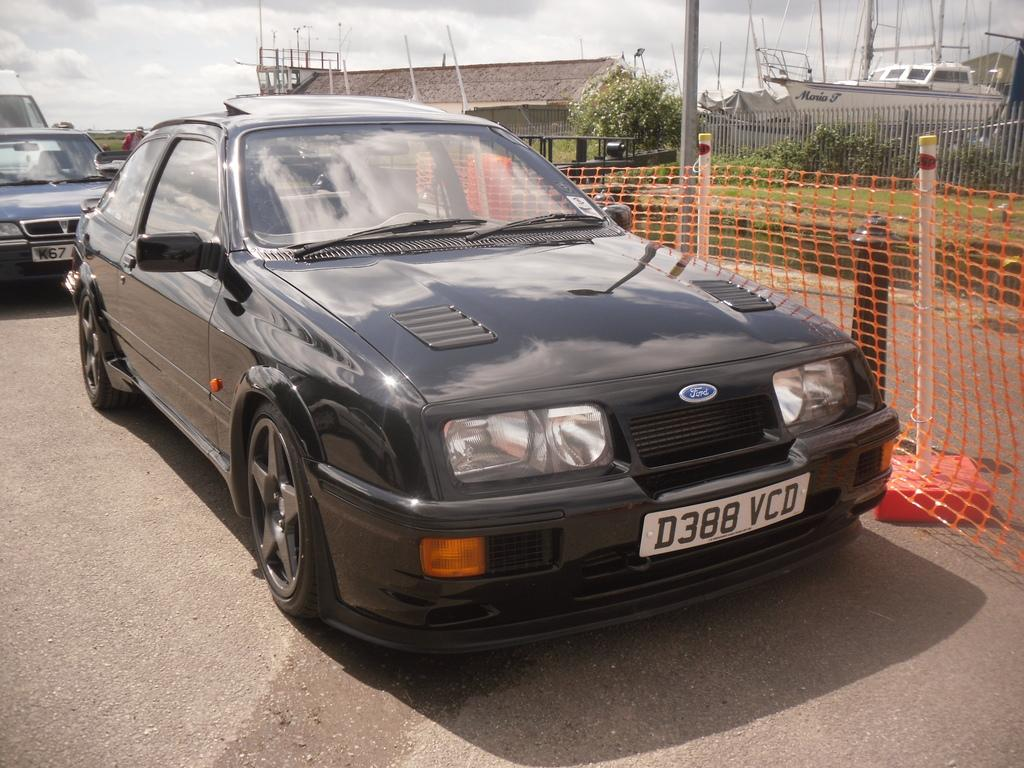What type of vehicles can be seen on the road in the image? There are cars on the road in the image. What is the purpose of the fence in the image? The purpose of the fence in the image is not explicitly stated, but it could be to mark a boundary or provide security. What type of structures are visible in the image? There are buildings in the image. What type of vegetation is present in the image? There are plants in the image. Can you tell me how many nuts are on the knee of the minister in the image? There is no minister or nuts present in the image. What type of minister is depicted in the image? There is no minister present in the image. 